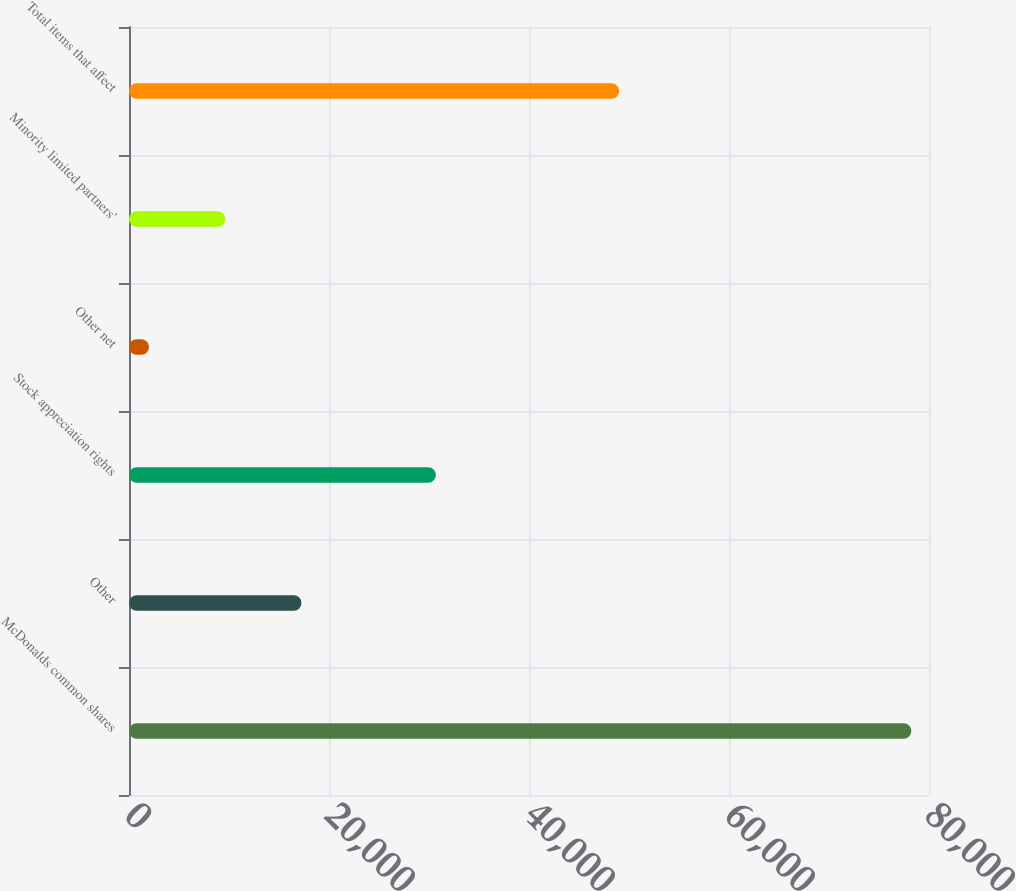<chart> <loc_0><loc_0><loc_500><loc_500><bar_chart><fcel>McDonalds common shares<fcel>Other<fcel>Stock appreciation rights<fcel>Other net<fcel>Minority limited partners'<fcel>Total items that affect<nl><fcel>78234<fcel>17246.8<fcel>30687<fcel>2000<fcel>9623.4<fcel>49014<nl></chart> 